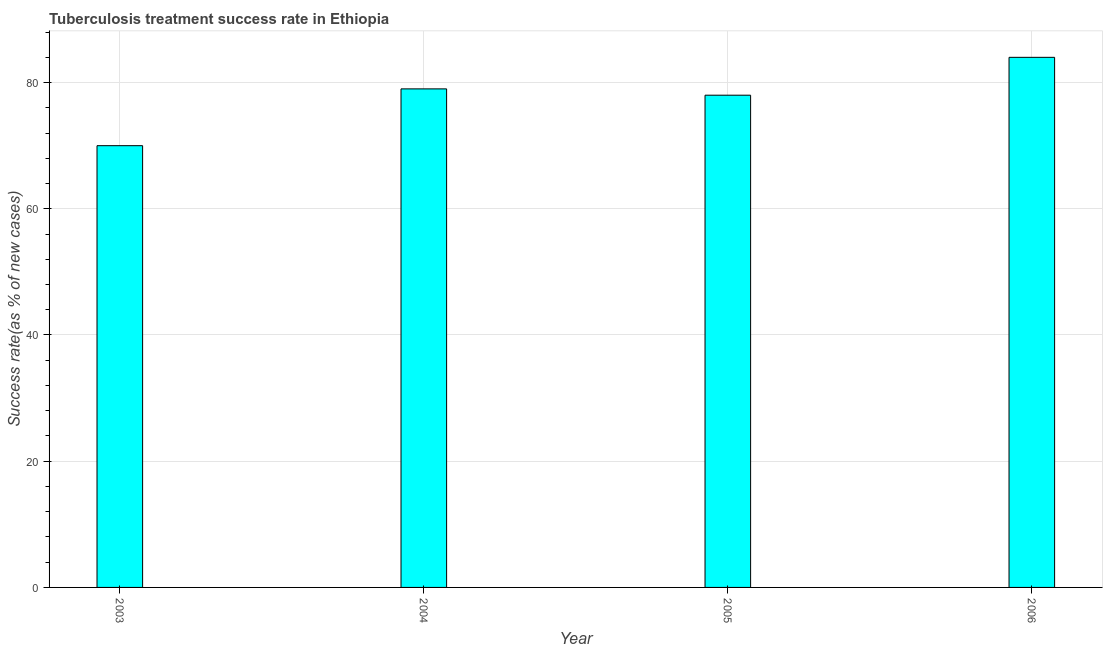Does the graph contain any zero values?
Offer a terse response. No. Does the graph contain grids?
Keep it short and to the point. Yes. What is the title of the graph?
Your answer should be very brief. Tuberculosis treatment success rate in Ethiopia. What is the label or title of the X-axis?
Ensure brevity in your answer.  Year. What is the label or title of the Y-axis?
Offer a terse response. Success rate(as % of new cases). Across all years, what is the maximum tuberculosis treatment success rate?
Give a very brief answer. 84. In which year was the tuberculosis treatment success rate minimum?
Keep it short and to the point. 2003. What is the sum of the tuberculosis treatment success rate?
Give a very brief answer. 311. What is the median tuberculosis treatment success rate?
Provide a succinct answer. 78.5. What is the ratio of the tuberculosis treatment success rate in 2003 to that in 2006?
Offer a terse response. 0.83. What is the difference between the highest and the second highest tuberculosis treatment success rate?
Your response must be concise. 5. What is the difference between the highest and the lowest tuberculosis treatment success rate?
Provide a succinct answer. 14. In how many years, is the tuberculosis treatment success rate greater than the average tuberculosis treatment success rate taken over all years?
Provide a short and direct response. 3. How many bars are there?
Your answer should be very brief. 4. Are all the bars in the graph horizontal?
Give a very brief answer. No. How many years are there in the graph?
Keep it short and to the point. 4. Are the values on the major ticks of Y-axis written in scientific E-notation?
Offer a terse response. No. What is the Success rate(as % of new cases) in 2004?
Your answer should be compact. 79. What is the Success rate(as % of new cases) in 2005?
Your answer should be very brief. 78. What is the difference between the Success rate(as % of new cases) in 2003 and 2004?
Offer a very short reply. -9. What is the difference between the Success rate(as % of new cases) in 2003 and 2005?
Your answer should be very brief. -8. What is the difference between the Success rate(as % of new cases) in 2004 and 2006?
Provide a succinct answer. -5. What is the difference between the Success rate(as % of new cases) in 2005 and 2006?
Keep it short and to the point. -6. What is the ratio of the Success rate(as % of new cases) in 2003 to that in 2004?
Provide a short and direct response. 0.89. What is the ratio of the Success rate(as % of new cases) in 2003 to that in 2005?
Ensure brevity in your answer.  0.9. What is the ratio of the Success rate(as % of new cases) in 2003 to that in 2006?
Keep it short and to the point. 0.83. What is the ratio of the Success rate(as % of new cases) in 2004 to that in 2005?
Your answer should be very brief. 1.01. What is the ratio of the Success rate(as % of new cases) in 2005 to that in 2006?
Keep it short and to the point. 0.93. 